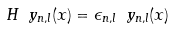<formula> <loc_0><loc_0><loc_500><loc_500>H \ y _ { n , l } ( x ) = \epsilon _ { n , l } \ y _ { n , l } ( x )</formula> 